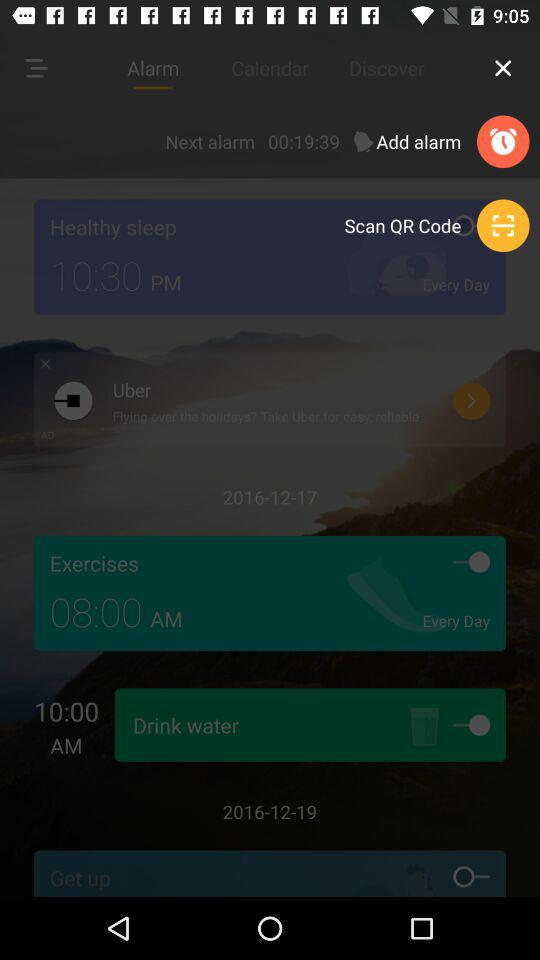How many of the reminders are HOT?
Answer the question using a single word or phrase. 2 